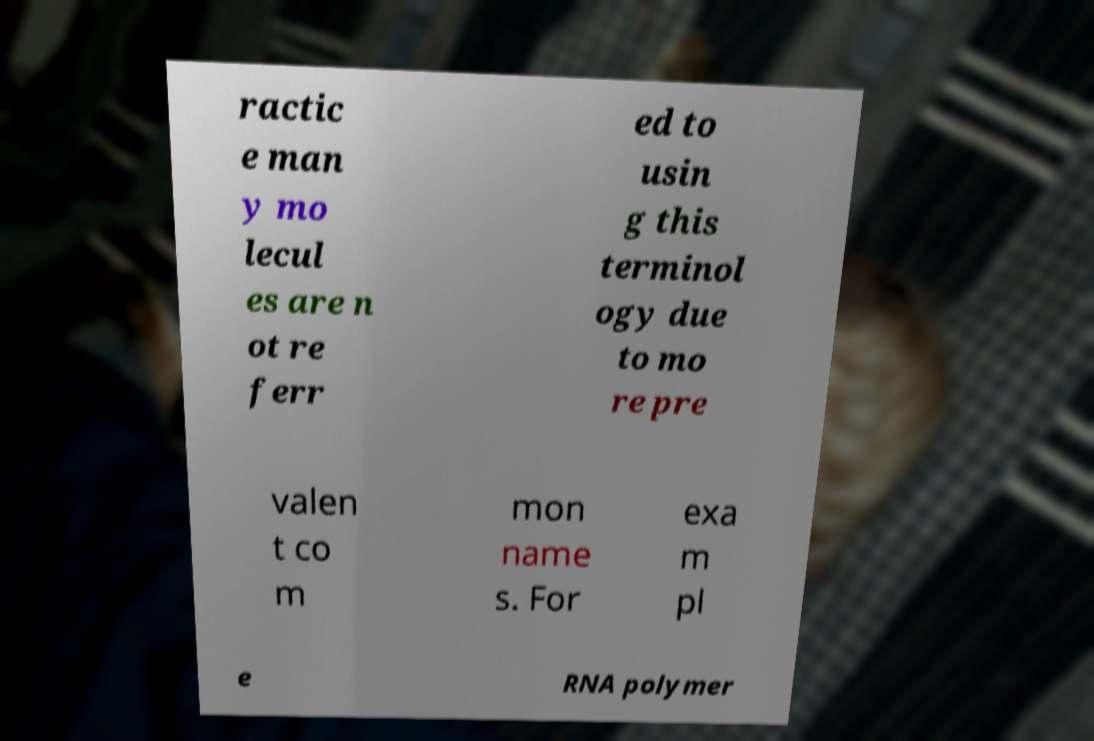Could you assist in decoding the text presented in this image and type it out clearly? ractic e man y mo lecul es are n ot re ferr ed to usin g this terminol ogy due to mo re pre valen t co m mon name s. For exa m pl e RNA polymer 